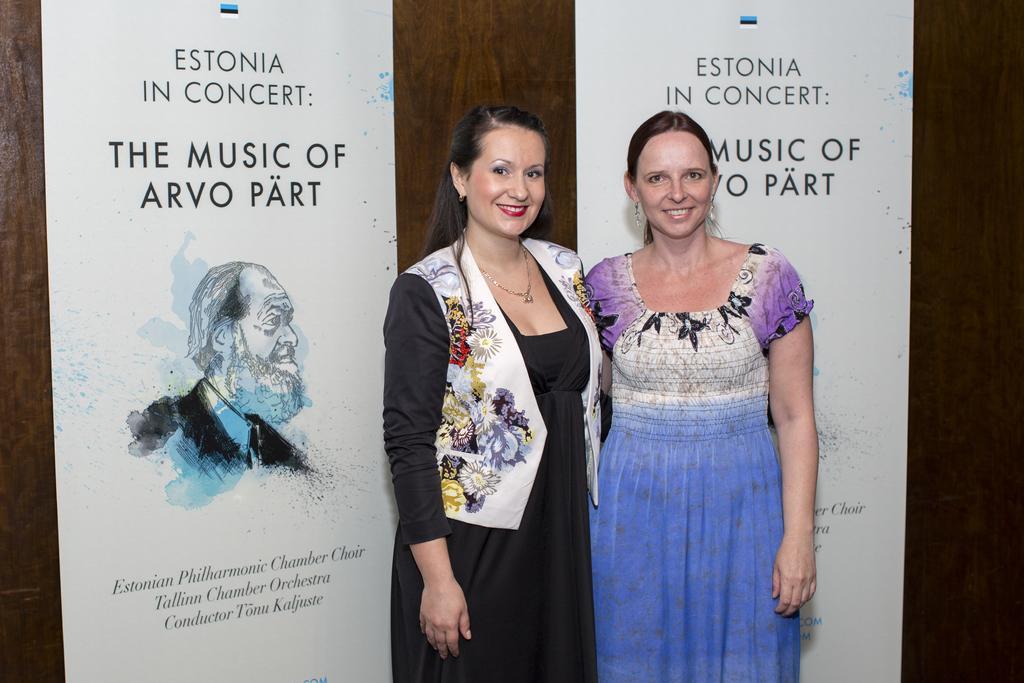Describe this image in one or two sentences. In this image I can see two women are standing in the front and I can also see smile on their faces. I can see the left one is wearing necklace. In the background I can see two white colour boards and on it I can see something is written. 